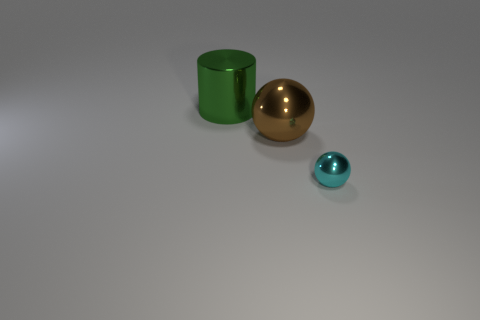There is a shiny ball that is on the right side of the metal sphere that is left of the cyan metal thing; what color is it?
Keep it short and to the point. Cyan. Is the size of the brown thing the same as the green shiny thing?
Keep it short and to the point. Yes. Is the material of the thing that is in front of the big sphere the same as the thing behind the big brown sphere?
Give a very brief answer. Yes. What shape is the large thing in front of the cylinder that is left of the metal ball that is behind the tiny cyan thing?
Your response must be concise. Sphere. Are there more big balls than large metal things?
Your response must be concise. No. Is there a small gray thing?
Your answer should be very brief. No. How many objects are either big metallic things that are behind the big brown metal ball or shiny objects on the right side of the green cylinder?
Offer a very short reply. 3. Do the cylinder and the big metallic ball have the same color?
Ensure brevity in your answer.  No. Are there fewer large brown shiny objects than large things?
Keep it short and to the point. Yes. There is a small cyan thing; are there any big brown things left of it?
Provide a short and direct response. Yes. 